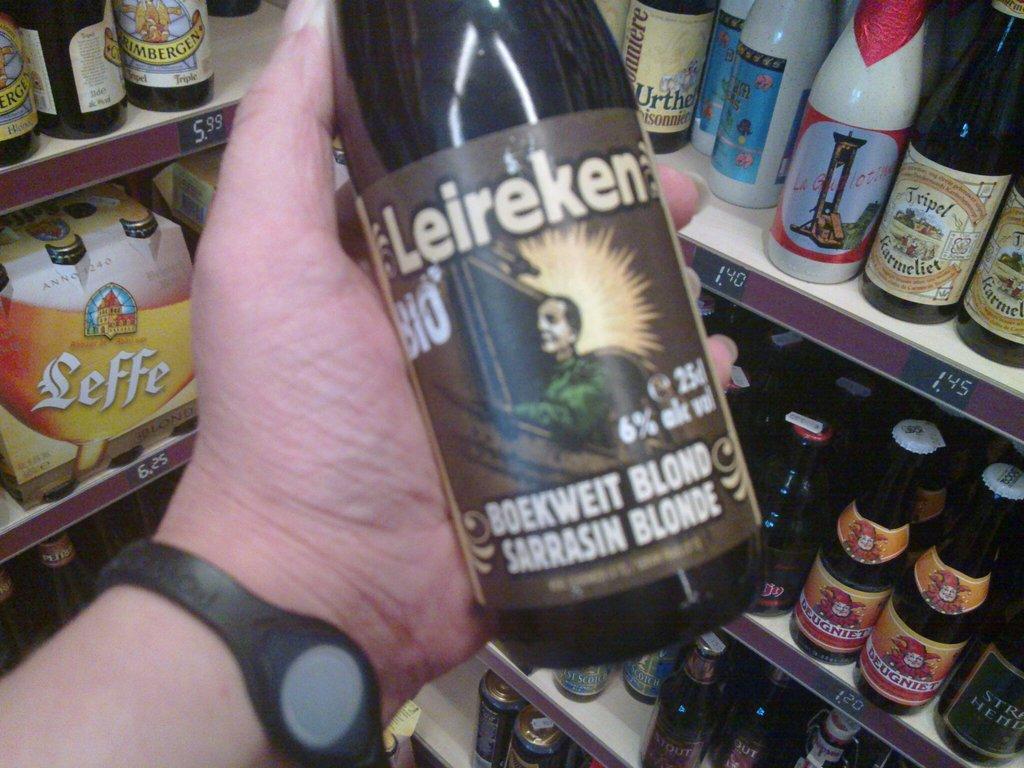What is the alcohol volume?
Keep it short and to the point. 6%. What is he holding?
Offer a terse response. Leireken. 